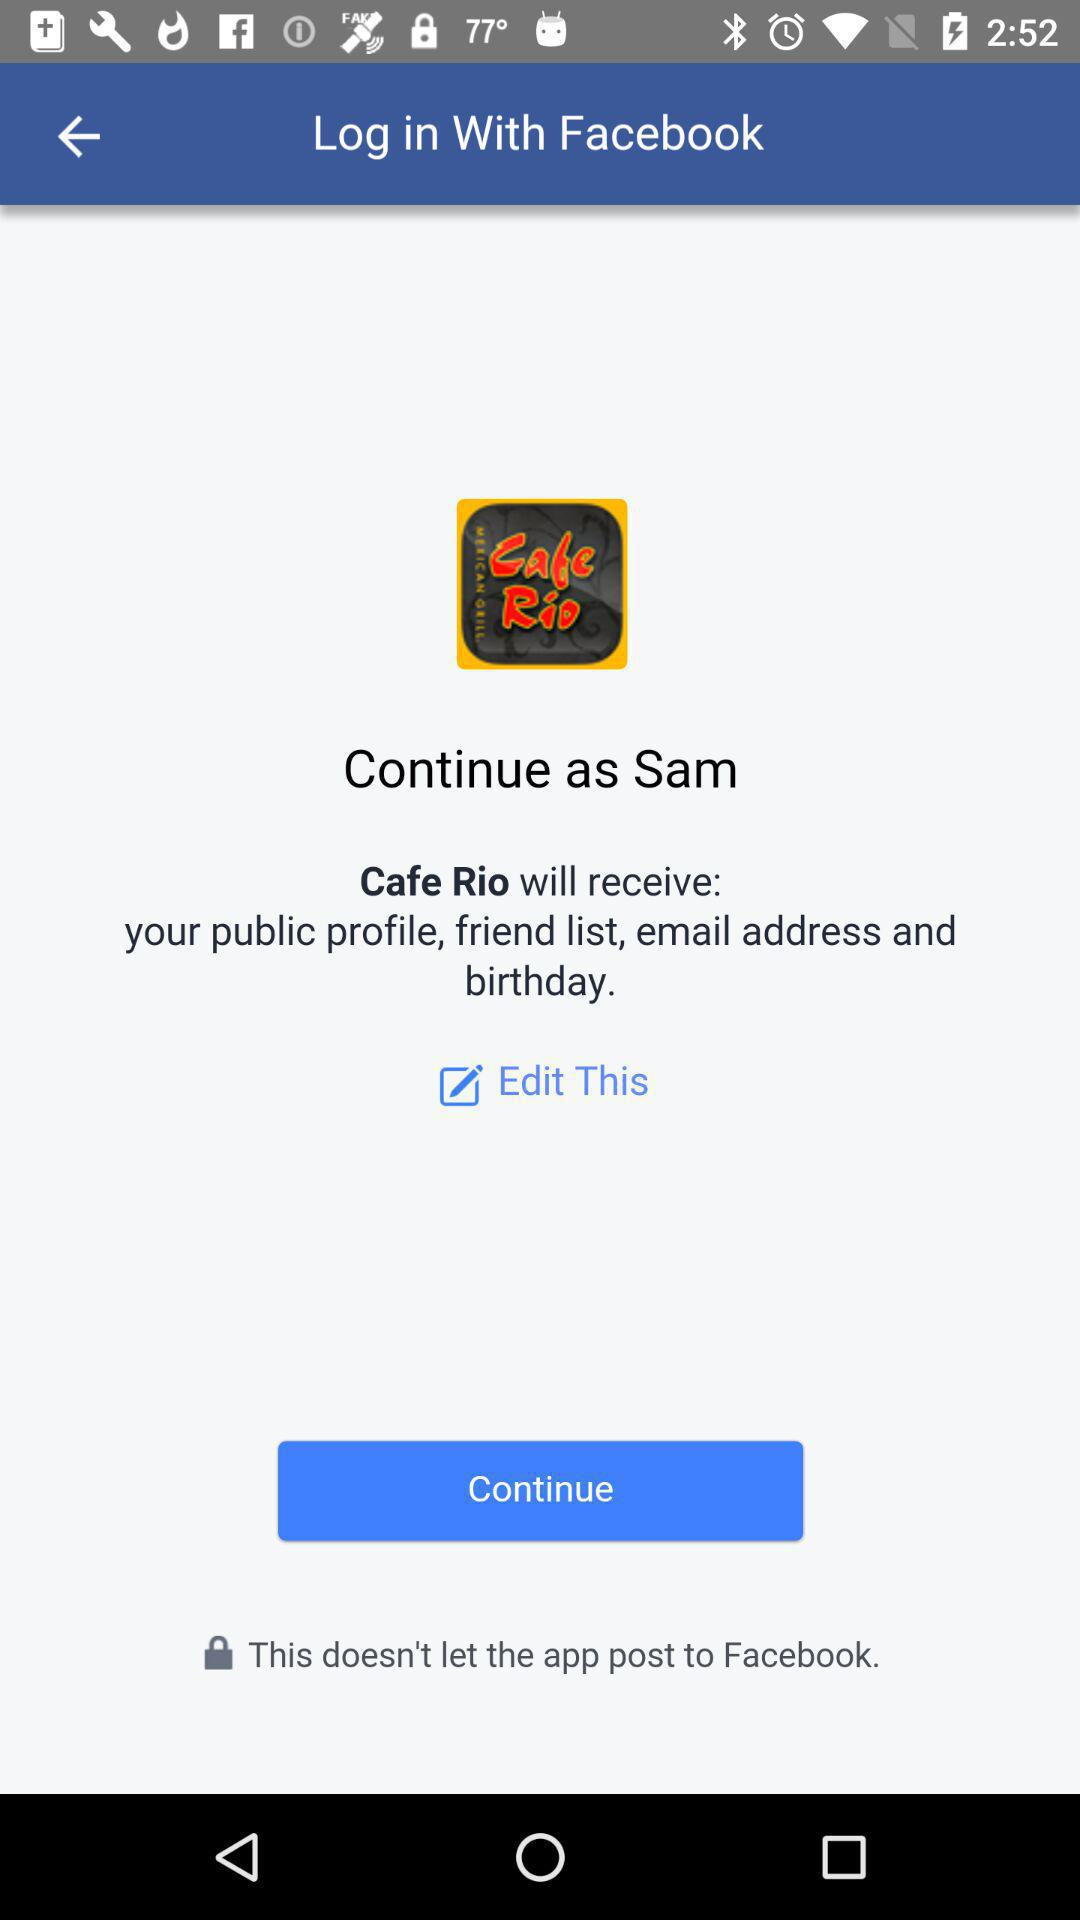What is the name of the user? The name of the user is "Sam". 